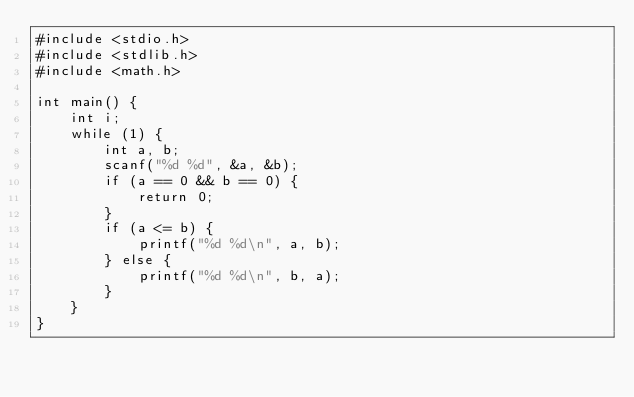<code> <loc_0><loc_0><loc_500><loc_500><_C_>#include <stdio.h>
#include <stdlib.h>
#include <math.h>

int main() {
	int i;
	while (1) {
		int a, b;
		scanf("%d %d", &a, &b);
		if (a == 0 && b == 0) {
			return 0;
		}
		if (a <= b) {
			printf("%d %d\n", a, b);
		} else {
			printf("%d %d\n", b, a);
		}
	}
}</code> 